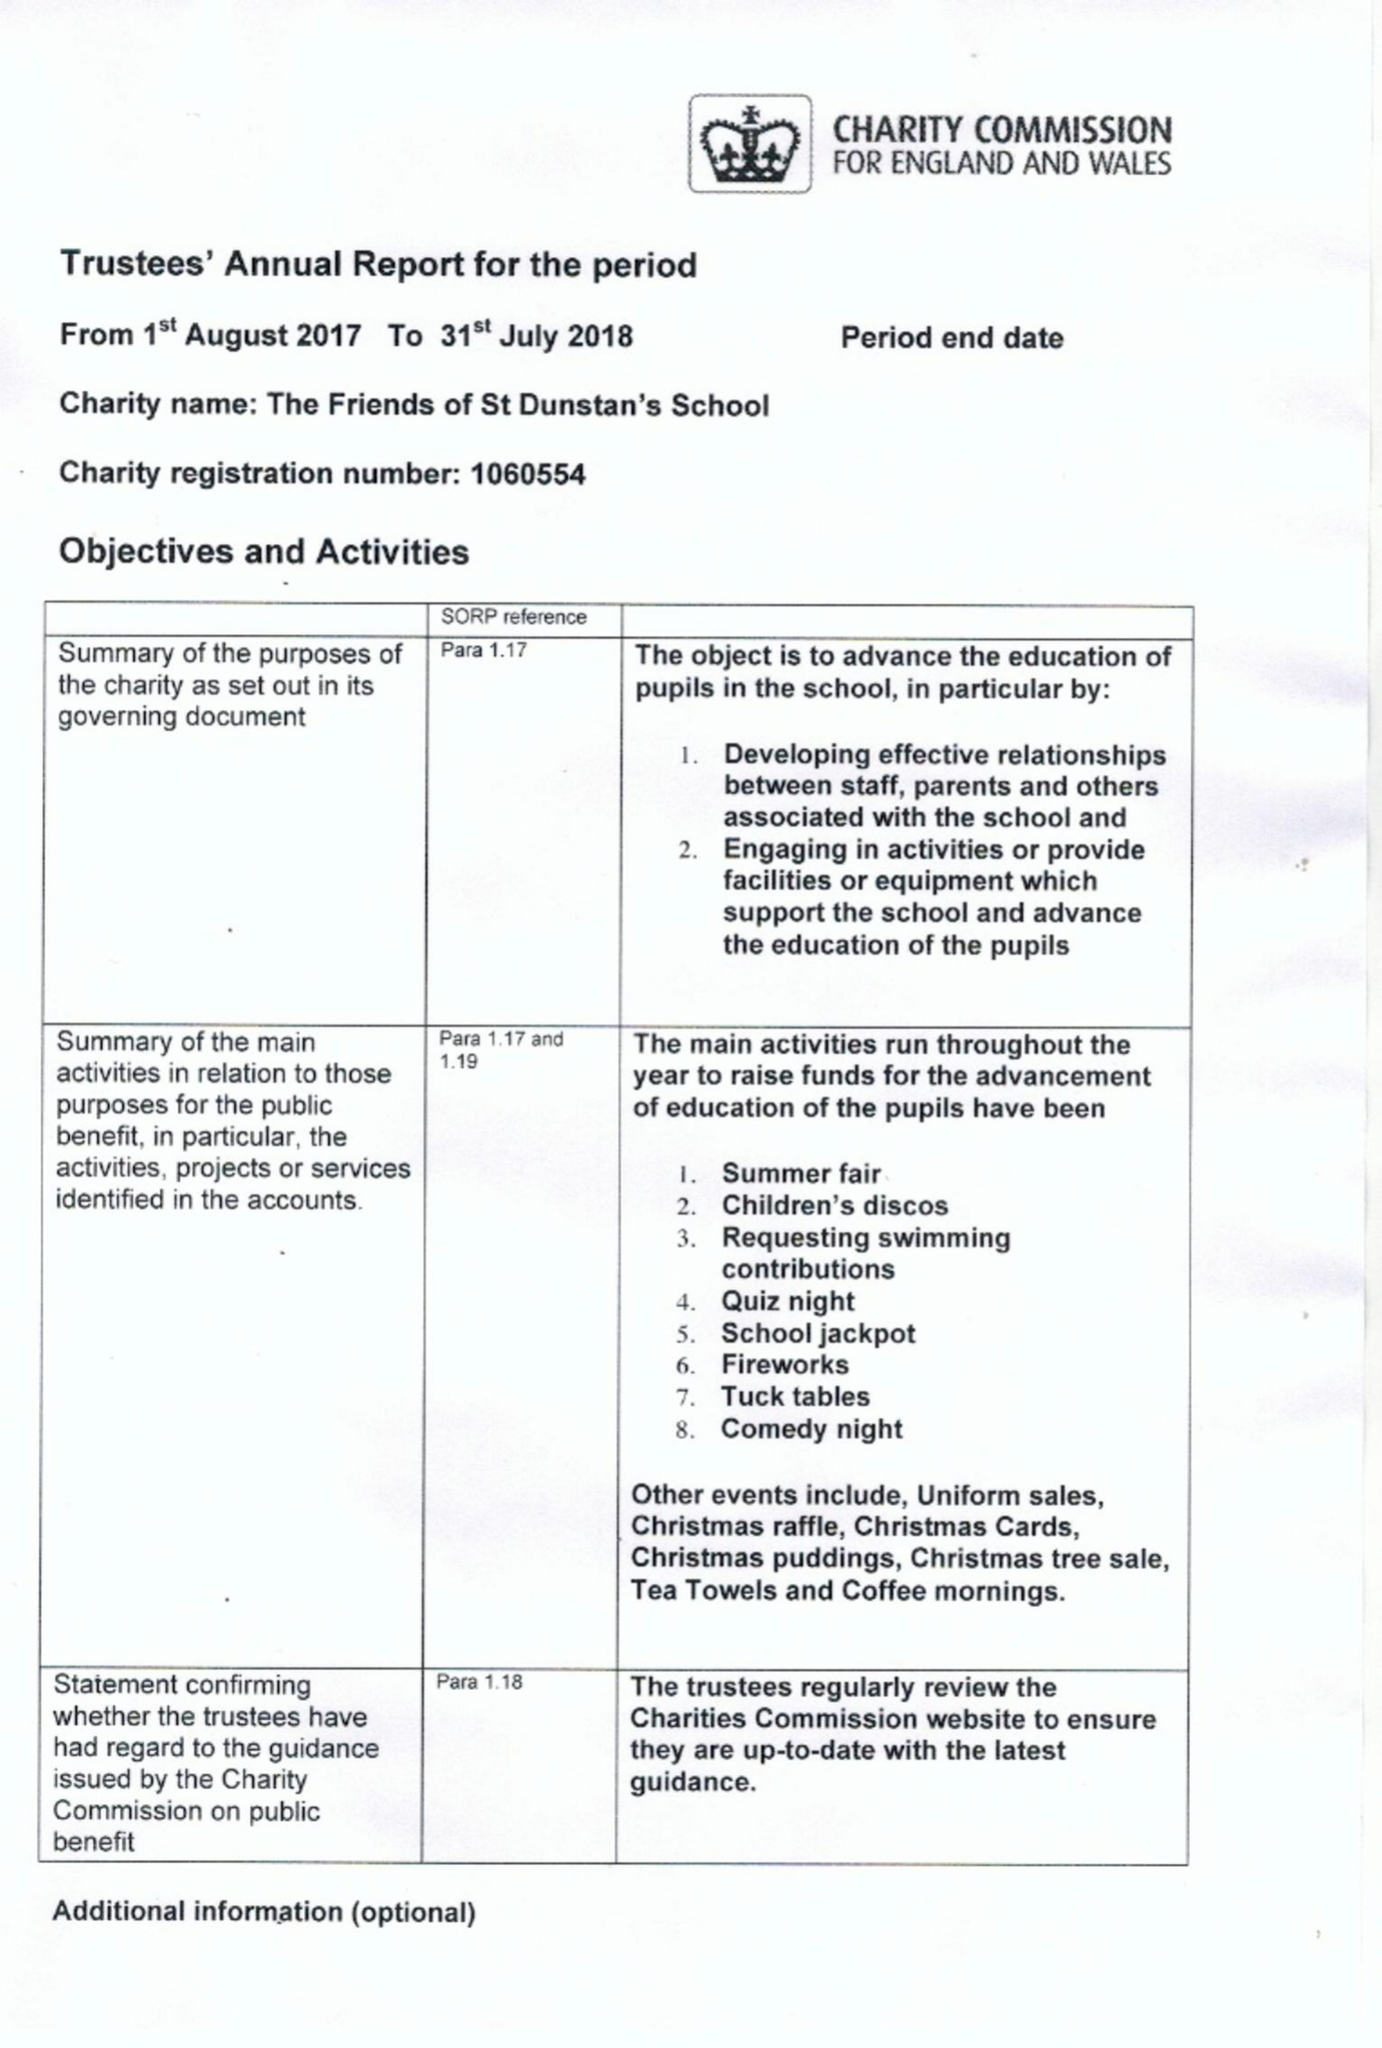What is the value for the income_annually_in_british_pounds?
Answer the question using a single word or phrase. 51732.00 